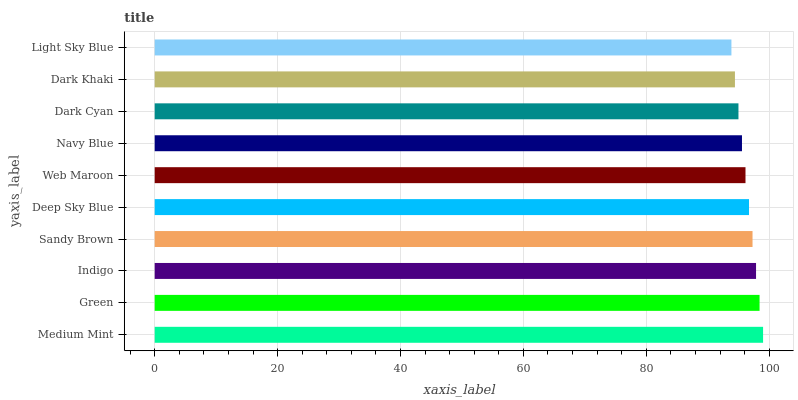Is Light Sky Blue the minimum?
Answer yes or no. Yes. Is Medium Mint the maximum?
Answer yes or no. Yes. Is Green the minimum?
Answer yes or no. No. Is Green the maximum?
Answer yes or no. No. Is Medium Mint greater than Green?
Answer yes or no. Yes. Is Green less than Medium Mint?
Answer yes or no. Yes. Is Green greater than Medium Mint?
Answer yes or no. No. Is Medium Mint less than Green?
Answer yes or no. No. Is Deep Sky Blue the high median?
Answer yes or no. Yes. Is Web Maroon the low median?
Answer yes or no. Yes. Is Web Maroon the high median?
Answer yes or no. No. Is Navy Blue the low median?
Answer yes or no. No. 